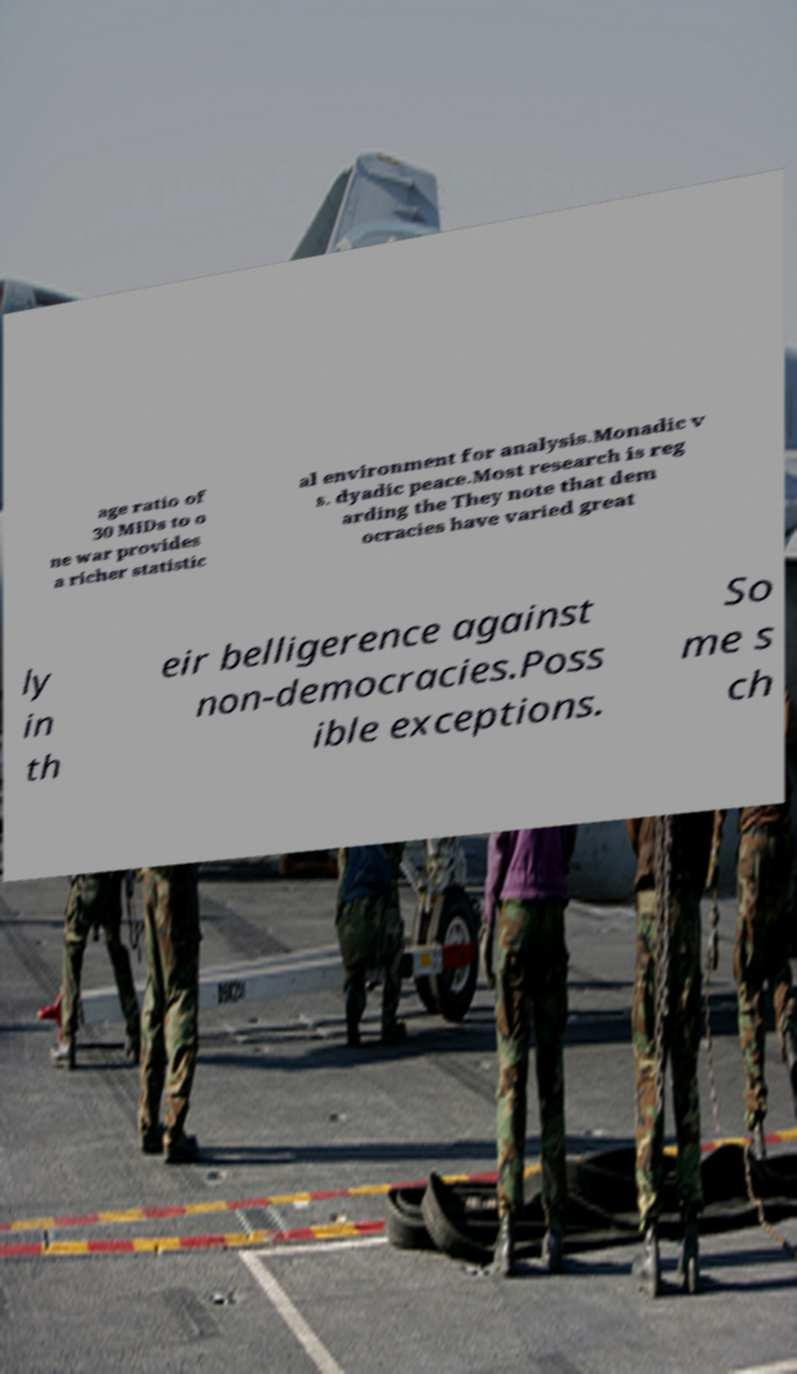Can you accurately transcribe the text from the provided image for me? age ratio of 30 MIDs to o ne war provides a richer statistic al environment for analysis.Monadic v s. dyadic peace.Most research is reg arding the They note that dem ocracies have varied great ly in th eir belligerence against non-democracies.Poss ible exceptions. So me s ch 